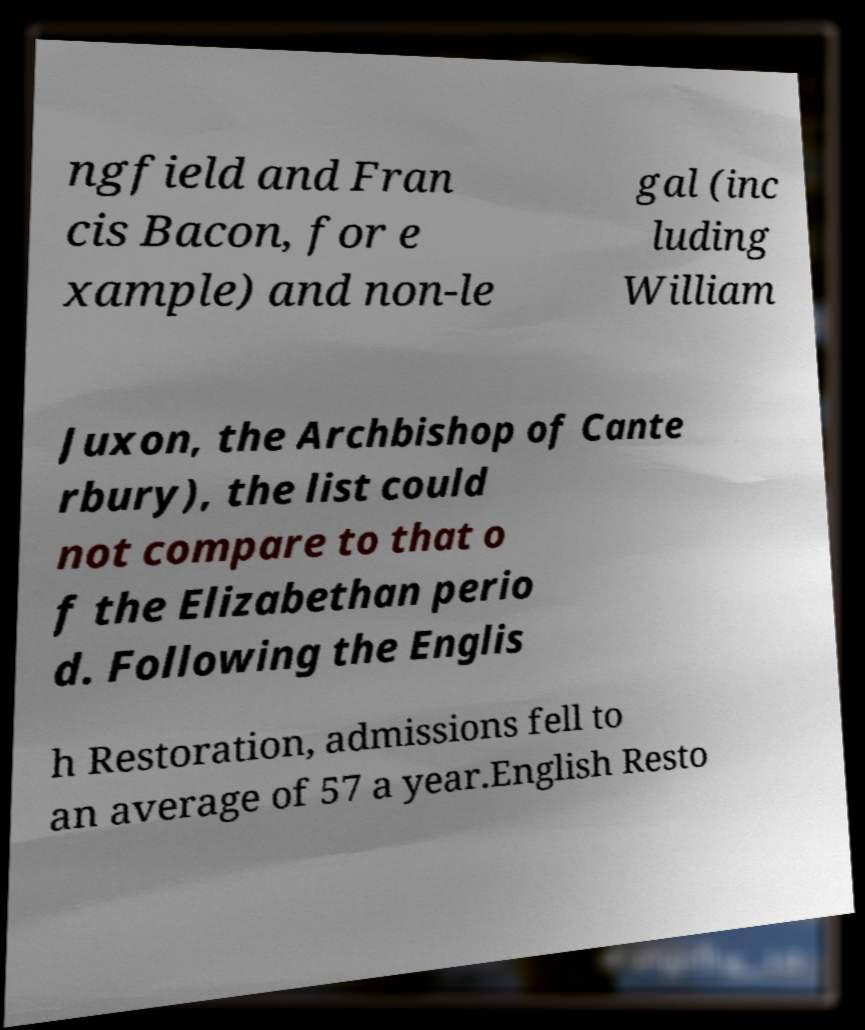Could you assist in decoding the text presented in this image and type it out clearly? ngfield and Fran cis Bacon, for e xample) and non-le gal (inc luding William Juxon, the Archbishop of Cante rbury), the list could not compare to that o f the Elizabethan perio d. Following the Englis h Restoration, admissions fell to an average of 57 a year.English Resto 